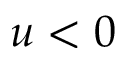<formula> <loc_0><loc_0><loc_500><loc_500>u < 0</formula> 